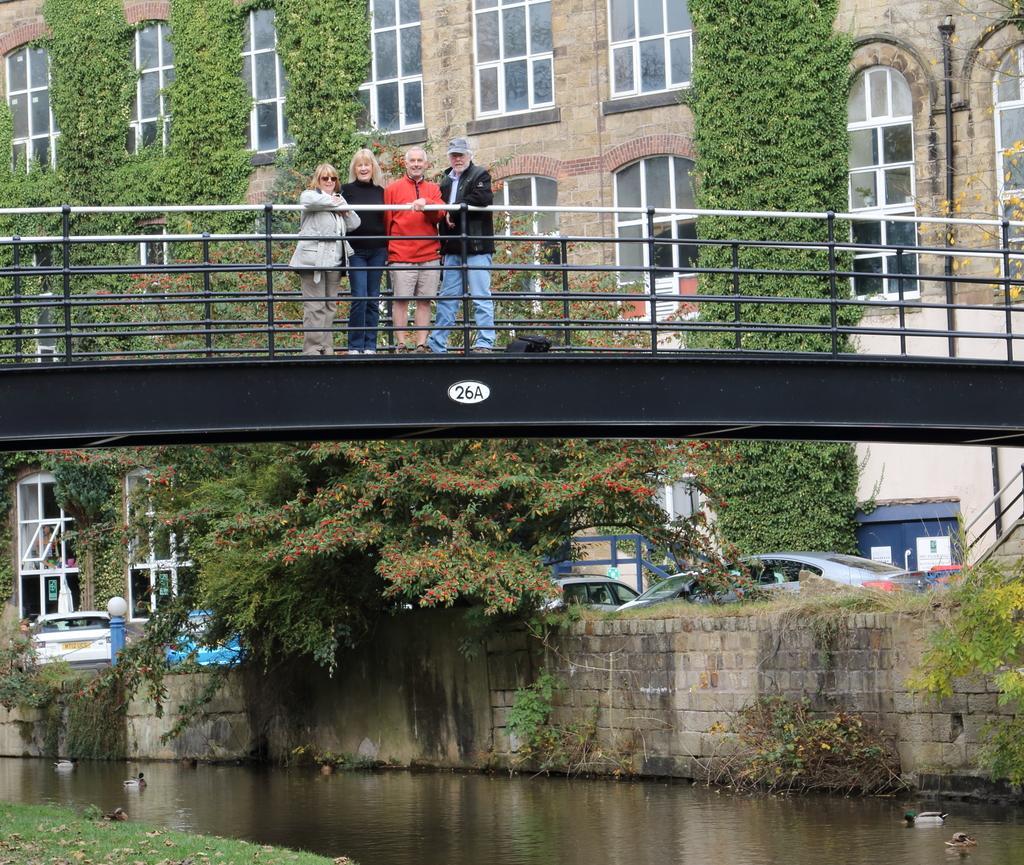Describe this image in one or two sentences. In this image we can see four people standing on the bridge. In the background we can see the buildings, trees, creepers, light pole and also the vehicles. We can also see the wall, water, dried leaves and also the grass. 